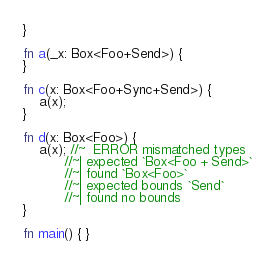Convert code to text. <code><loc_0><loc_0><loc_500><loc_500><_Rust_>}

fn a(_x: Box<Foo+Send>) {
}

fn c(x: Box<Foo+Sync+Send>) {
    a(x);
}

fn d(x: Box<Foo>) {
    a(x); //~  ERROR mismatched types
          //~| expected `Box<Foo + Send>`
          //~| found `Box<Foo>`
          //~| expected bounds `Send`
          //~| found no bounds
}

fn main() { }
</code> 